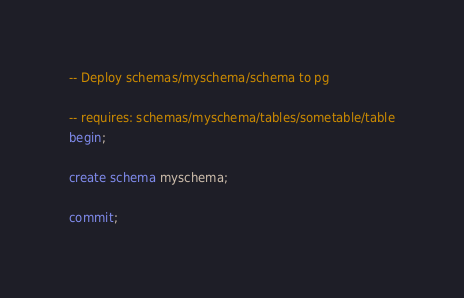Convert code to text. <code><loc_0><loc_0><loc_500><loc_500><_SQL_>-- Deploy schemas/myschema/schema to pg

-- requires: schemas/myschema/tables/sometable/table
begin;

create schema myschema;

commit;
</code> 